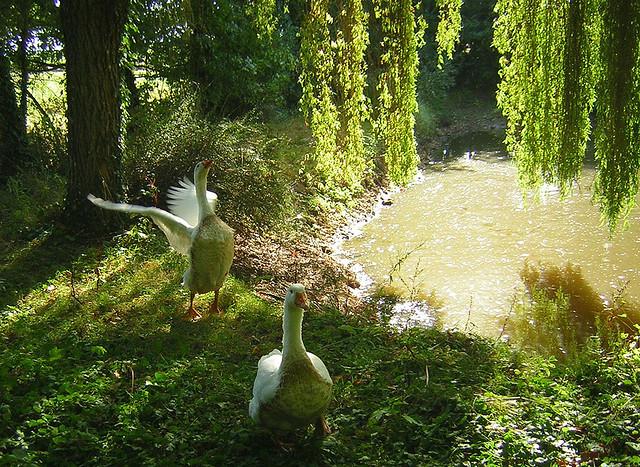What is the back goose doing?
Be succinct. Flapping wings. How many geese are there?
Keep it brief. 2. Are the geese in the water?
Quick response, please. No. 